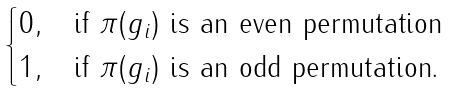<formula> <loc_0><loc_0><loc_500><loc_500>\begin{cases} 0 , & \text {if $\pi(g_{i})$ is an even permutation} \\ 1 , & \text {if $\pi(g_{i})$ is an odd permutation.} \end{cases}</formula> 